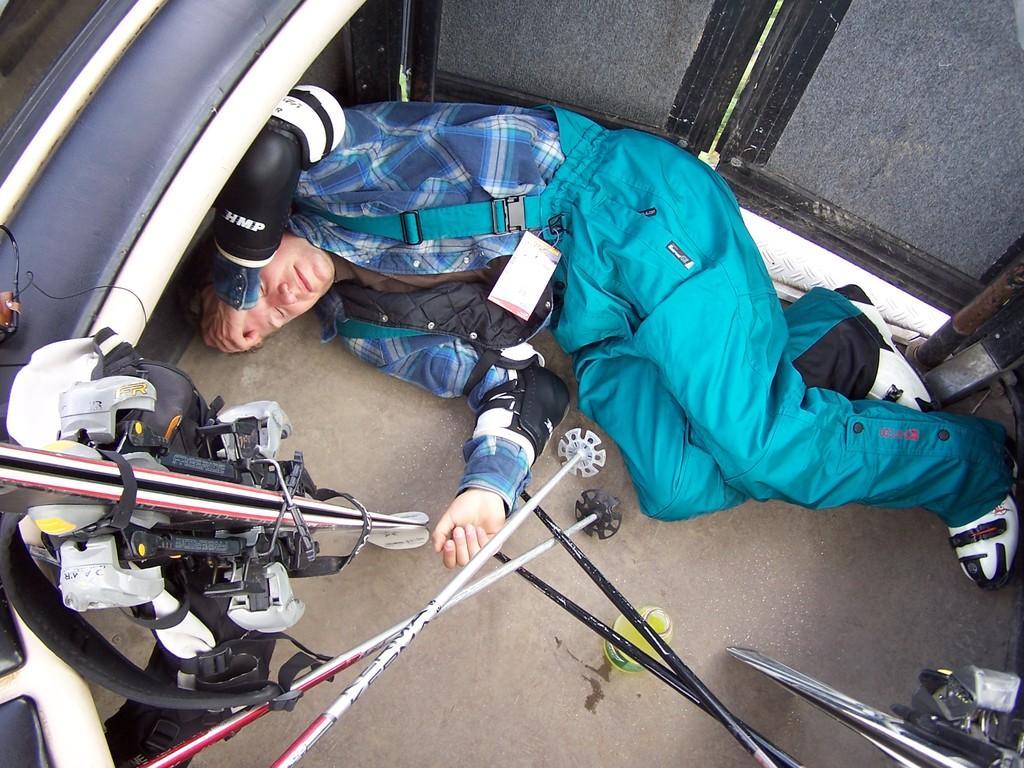In one or two sentences, can you explain what this image depicts? In this image I can see a man is lying on the floor. I can see he is wearing blue colour dress, elbow guards and white colour shoes. On the bottom side of this image I can see few sticks, a bottle and on the left side of this image I can see few skiboards. 